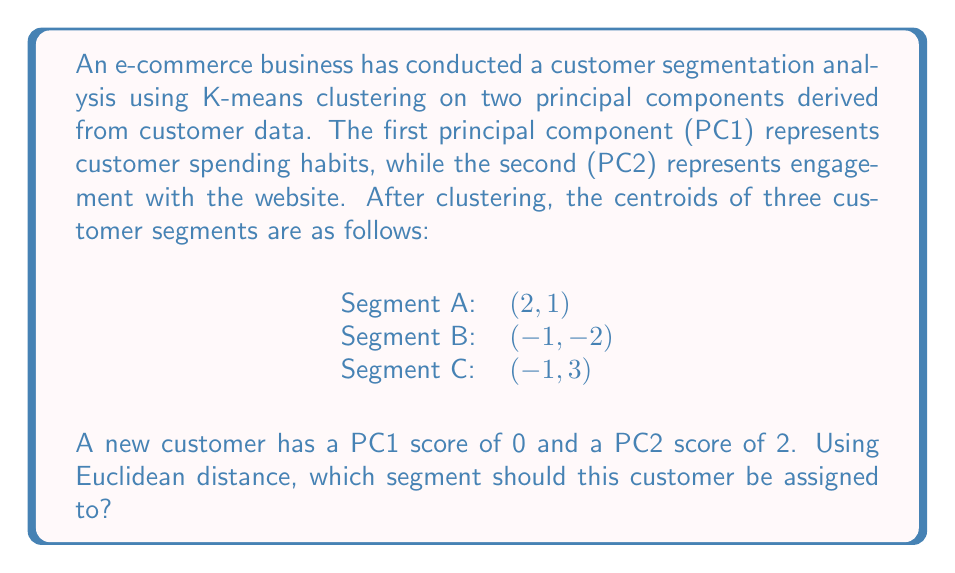Help me with this question. To determine which segment the new customer should be assigned to, we need to calculate the Euclidean distance between the new customer's point (0, 2) and each of the segment centroids. The segment with the shortest distance will be the one to which the customer is assigned.

The Euclidean distance formula in two dimensions is:

$$d = \sqrt{(x_2 - x_1)^2 + (y_2 - y_1)^2}$$

Where $(x_1, y_1)$ is the new customer's point and $(x_2, y_2)$ is the centroid of each segment.

1. Distance to Segment A (2, 1):
   $$d_A = \sqrt{(2 - 0)^2 + (1 - 2)^2} = \sqrt{4 + 1} = \sqrt{5} \approx 2.24$$

2. Distance to Segment B (-1, -2):
   $$d_B = \sqrt{(-1 - 0)^2 + (-2 - 2)^2} = \sqrt{1 + 16} = \sqrt{17} \approx 4.12$$

3. Distance to Segment C (-1, 3):
   $$d_C = \sqrt{(-1 - 0)^2 + (3 - 2)^2} = \sqrt{1 + 1} = \sqrt{2} \approx 1.41$$

The shortest distance is to Segment C, with a distance of approximately 1.41.
Answer: Segment C 